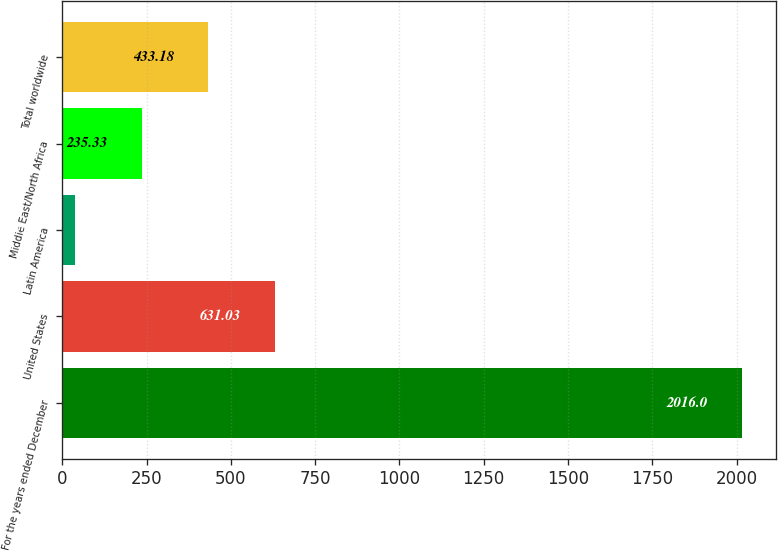Convert chart. <chart><loc_0><loc_0><loc_500><loc_500><bar_chart><fcel>For the years ended December<fcel>United States<fcel>Latin America<fcel>Middle East/North Africa<fcel>Total worldwide<nl><fcel>2016<fcel>631.03<fcel>37.48<fcel>235.33<fcel>433.18<nl></chart> 